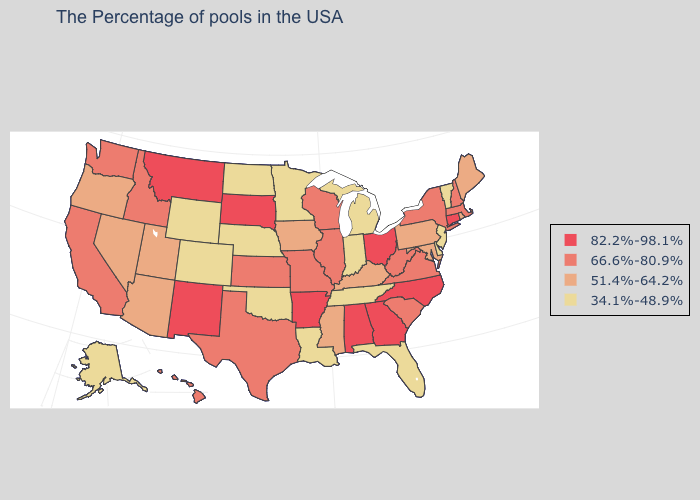Among the states that border New Mexico , which have the highest value?
Keep it brief. Texas. Among the states that border North Dakota , does Montana have the highest value?
Quick response, please. Yes. Is the legend a continuous bar?
Write a very short answer. No. Which states hav the highest value in the South?
Write a very short answer. North Carolina, Georgia, Alabama, Arkansas. Among the states that border Alabama , does Mississippi have the lowest value?
Write a very short answer. No. Among the states that border Pennsylvania , does New Jersey have the lowest value?
Be succinct. Yes. Name the states that have a value in the range 66.6%-80.9%?
Be succinct. Massachusetts, New Hampshire, New York, Virginia, South Carolina, West Virginia, Wisconsin, Illinois, Missouri, Kansas, Texas, Idaho, California, Washington, Hawaii. Does Nevada have the lowest value in the West?
Concise answer only. No. Name the states that have a value in the range 51.4%-64.2%?
Give a very brief answer. Maine, Rhode Island, Maryland, Pennsylvania, Kentucky, Mississippi, Iowa, Utah, Arizona, Nevada, Oregon. Name the states that have a value in the range 34.1%-48.9%?
Concise answer only. Vermont, New Jersey, Delaware, Florida, Michigan, Indiana, Tennessee, Louisiana, Minnesota, Nebraska, Oklahoma, North Dakota, Wyoming, Colorado, Alaska. Does the first symbol in the legend represent the smallest category?
Give a very brief answer. No. What is the lowest value in the West?
Be succinct. 34.1%-48.9%. Among the states that border Oklahoma , does Colorado have the highest value?
Short answer required. No. Name the states that have a value in the range 66.6%-80.9%?
Concise answer only. Massachusetts, New Hampshire, New York, Virginia, South Carolina, West Virginia, Wisconsin, Illinois, Missouri, Kansas, Texas, Idaho, California, Washington, Hawaii. Name the states that have a value in the range 82.2%-98.1%?
Keep it brief. Connecticut, North Carolina, Ohio, Georgia, Alabama, Arkansas, South Dakota, New Mexico, Montana. 